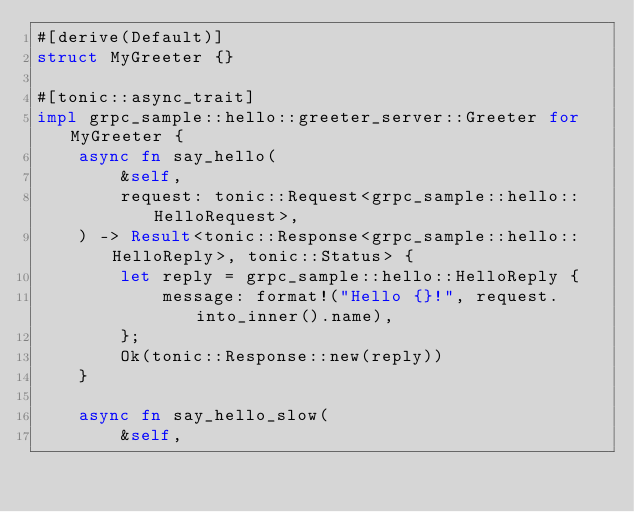<code> <loc_0><loc_0><loc_500><loc_500><_Rust_>#[derive(Default)]
struct MyGreeter {}

#[tonic::async_trait]
impl grpc_sample::hello::greeter_server::Greeter for MyGreeter {
    async fn say_hello(
        &self,
        request: tonic::Request<grpc_sample::hello::HelloRequest>,
    ) -> Result<tonic::Response<grpc_sample::hello::HelloReply>, tonic::Status> {
        let reply = grpc_sample::hello::HelloReply {
            message: format!("Hello {}!", request.into_inner().name),
        };
        Ok(tonic::Response::new(reply))
    }

    async fn say_hello_slow(
        &self,</code> 